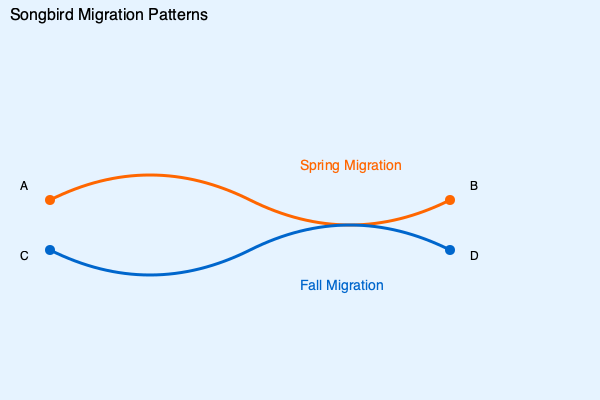Based on the migration patterns depicted in the world map, which route would likely inspire more diverse birdsongs for a violinist's composition, and why? To answer this question, let's analyze the migration patterns shown in the map:

1. The orange line represents the spring migration from point A to point B.
2. The blue line represents the fall migration from point C to point D.

Step 1: Consider the timing of migrations
- Spring migration (A to B) occurs when birds are traveling to their breeding grounds.
- Fall migration (C to D) occurs when birds are returning to their wintering grounds.

Step 2: Analyze bird behavior during each migration
- During spring migration, birds are more active and vocal as they establish territories and attract mates.
- Male birds, in particular, sing more frequently and elaborately during the breeding season.

Step 3: Evaluate the diversity of songs
- Spring migration coincides with the breeding season, so birds are likely to showcase a wider variety of songs and calls.
- Fall migration is generally quieter, with birds focusing more on feeding and conserving energy for the long journey.

Step 4: Consider the violinist's perspective
- A violinist seeking inspiration for classical music compositions would benefit from a greater variety of birdsongs and calls.
- The more diverse and frequent vocalizations during spring migration would provide richer source material for musical interpretation.
Answer: Spring migration route (A to B) 